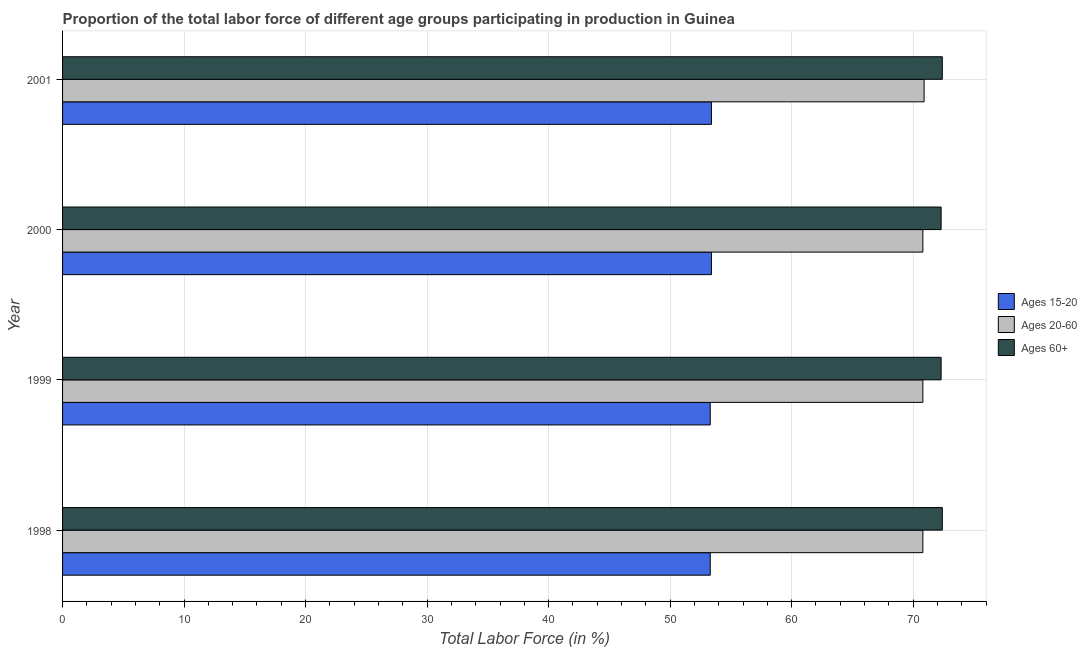Are the number of bars per tick equal to the number of legend labels?
Offer a very short reply. Yes. How many bars are there on the 4th tick from the bottom?
Your answer should be very brief. 3. What is the label of the 2nd group of bars from the top?
Ensure brevity in your answer.  2000. In how many cases, is the number of bars for a given year not equal to the number of legend labels?
Keep it short and to the point. 0. What is the percentage of labor force above age 60 in 2000?
Offer a terse response. 72.3. Across all years, what is the maximum percentage of labor force above age 60?
Keep it short and to the point. 72.4. Across all years, what is the minimum percentage of labor force within the age group 15-20?
Offer a terse response. 53.3. What is the total percentage of labor force within the age group 15-20 in the graph?
Offer a terse response. 213.4. What is the difference between the percentage of labor force within the age group 15-20 in 1999 and that in 2001?
Your response must be concise. -0.1. What is the difference between the percentage of labor force within the age group 15-20 in 1998 and the percentage of labor force above age 60 in 1999?
Ensure brevity in your answer.  -19. What is the average percentage of labor force above age 60 per year?
Your answer should be very brief. 72.35. In the year 2001, what is the difference between the percentage of labor force within the age group 20-60 and percentage of labor force within the age group 15-20?
Give a very brief answer. 17.5. What is the ratio of the percentage of labor force within the age group 20-60 in 1998 to that in 2000?
Your response must be concise. 1. Is the difference between the percentage of labor force above age 60 in 1998 and 1999 greater than the difference between the percentage of labor force within the age group 20-60 in 1998 and 1999?
Provide a succinct answer. Yes. What is the difference between the highest and the second highest percentage of labor force within the age group 15-20?
Your response must be concise. 0. What is the difference between the highest and the lowest percentage of labor force within the age group 15-20?
Provide a short and direct response. 0.1. In how many years, is the percentage of labor force within the age group 20-60 greater than the average percentage of labor force within the age group 20-60 taken over all years?
Your answer should be very brief. 1. Is the sum of the percentage of labor force above age 60 in 1998 and 2000 greater than the maximum percentage of labor force within the age group 20-60 across all years?
Your answer should be compact. Yes. What does the 1st bar from the top in 1998 represents?
Offer a very short reply. Ages 60+. What does the 2nd bar from the bottom in 1998 represents?
Offer a terse response. Ages 20-60. Is it the case that in every year, the sum of the percentage of labor force within the age group 15-20 and percentage of labor force within the age group 20-60 is greater than the percentage of labor force above age 60?
Offer a terse response. Yes. How many bars are there?
Your answer should be compact. 12. Are all the bars in the graph horizontal?
Provide a short and direct response. Yes. Does the graph contain any zero values?
Offer a very short reply. No. Where does the legend appear in the graph?
Your response must be concise. Center right. How many legend labels are there?
Provide a short and direct response. 3. What is the title of the graph?
Ensure brevity in your answer.  Proportion of the total labor force of different age groups participating in production in Guinea. Does "Agricultural raw materials" appear as one of the legend labels in the graph?
Your response must be concise. No. What is the label or title of the X-axis?
Give a very brief answer. Total Labor Force (in %). What is the Total Labor Force (in %) in Ages 15-20 in 1998?
Keep it short and to the point. 53.3. What is the Total Labor Force (in %) of Ages 20-60 in 1998?
Ensure brevity in your answer.  70.8. What is the Total Labor Force (in %) in Ages 60+ in 1998?
Give a very brief answer. 72.4. What is the Total Labor Force (in %) of Ages 15-20 in 1999?
Ensure brevity in your answer.  53.3. What is the Total Labor Force (in %) of Ages 20-60 in 1999?
Your answer should be compact. 70.8. What is the Total Labor Force (in %) of Ages 60+ in 1999?
Offer a very short reply. 72.3. What is the Total Labor Force (in %) in Ages 15-20 in 2000?
Your response must be concise. 53.4. What is the Total Labor Force (in %) of Ages 20-60 in 2000?
Keep it short and to the point. 70.8. What is the Total Labor Force (in %) in Ages 60+ in 2000?
Keep it short and to the point. 72.3. What is the Total Labor Force (in %) of Ages 15-20 in 2001?
Your answer should be compact. 53.4. What is the Total Labor Force (in %) in Ages 20-60 in 2001?
Offer a very short reply. 70.9. What is the Total Labor Force (in %) of Ages 60+ in 2001?
Provide a short and direct response. 72.4. Across all years, what is the maximum Total Labor Force (in %) of Ages 15-20?
Ensure brevity in your answer.  53.4. Across all years, what is the maximum Total Labor Force (in %) in Ages 20-60?
Offer a terse response. 70.9. Across all years, what is the maximum Total Labor Force (in %) in Ages 60+?
Give a very brief answer. 72.4. Across all years, what is the minimum Total Labor Force (in %) in Ages 15-20?
Keep it short and to the point. 53.3. Across all years, what is the minimum Total Labor Force (in %) in Ages 20-60?
Ensure brevity in your answer.  70.8. Across all years, what is the minimum Total Labor Force (in %) in Ages 60+?
Your answer should be compact. 72.3. What is the total Total Labor Force (in %) in Ages 15-20 in the graph?
Your answer should be very brief. 213.4. What is the total Total Labor Force (in %) of Ages 20-60 in the graph?
Offer a very short reply. 283.3. What is the total Total Labor Force (in %) of Ages 60+ in the graph?
Give a very brief answer. 289.4. What is the difference between the Total Labor Force (in %) of Ages 15-20 in 1998 and that in 1999?
Provide a succinct answer. 0. What is the difference between the Total Labor Force (in %) in Ages 15-20 in 1998 and that in 2000?
Your answer should be very brief. -0.1. What is the difference between the Total Labor Force (in %) of Ages 20-60 in 1998 and that in 2000?
Your answer should be very brief. 0. What is the difference between the Total Labor Force (in %) in Ages 60+ in 1998 and that in 2000?
Your answer should be compact. 0.1. What is the difference between the Total Labor Force (in %) in Ages 60+ in 1998 and that in 2001?
Provide a short and direct response. 0. What is the difference between the Total Labor Force (in %) in Ages 20-60 in 1999 and that in 2000?
Ensure brevity in your answer.  0. What is the difference between the Total Labor Force (in %) in Ages 60+ in 1999 and that in 2000?
Your response must be concise. 0. What is the difference between the Total Labor Force (in %) in Ages 60+ in 2000 and that in 2001?
Your response must be concise. -0.1. What is the difference between the Total Labor Force (in %) in Ages 15-20 in 1998 and the Total Labor Force (in %) in Ages 20-60 in 1999?
Ensure brevity in your answer.  -17.5. What is the difference between the Total Labor Force (in %) in Ages 15-20 in 1998 and the Total Labor Force (in %) in Ages 20-60 in 2000?
Your response must be concise. -17.5. What is the difference between the Total Labor Force (in %) of Ages 20-60 in 1998 and the Total Labor Force (in %) of Ages 60+ in 2000?
Provide a succinct answer. -1.5. What is the difference between the Total Labor Force (in %) in Ages 15-20 in 1998 and the Total Labor Force (in %) in Ages 20-60 in 2001?
Your response must be concise. -17.6. What is the difference between the Total Labor Force (in %) in Ages 15-20 in 1998 and the Total Labor Force (in %) in Ages 60+ in 2001?
Provide a short and direct response. -19.1. What is the difference between the Total Labor Force (in %) of Ages 15-20 in 1999 and the Total Labor Force (in %) of Ages 20-60 in 2000?
Give a very brief answer. -17.5. What is the difference between the Total Labor Force (in %) of Ages 15-20 in 1999 and the Total Labor Force (in %) of Ages 20-60 in 2001?
Your response must be concise. -17.6. What is the difference between the Total Labor Force (in %) in Ages 15-20 in 1999 and the Total Labor Force (in %) in Ages 60+ in 2001?
Offer a terse response. -19.1. What is the difference between the Total Labor Force (in %) of Ages 20-60 in 1999 and the Total Labor Force (in %) of Ages 60+ in 2001?
Ensure brevity in your answer.  -1.6. What is the difference between the Total Labor Force (in %) of Ages 15-20 in 2000 and the Total Labor Force (in %) of Ages 20-60 in 2001?
Your answer should be very brief. -17.5. What is the difference between the Total Labor Force (in %) of Ages 20-60 in 2000 and the Total Labor Force (in %) of Ages 60+ in 2001?
Keep it short and to the point. -1.6. What is the average Total Labor Force (in %) of Ages 15-20 per year?
Make the answer very short. 53.35. What is the average Total Labor Force (in %) in Ages 20-60 per year?
Provide a short and direct response. 70.83. What is the average Total Labor Force (in %) of Ages 60+ per year?
Your answer should be very brief. 72.35. In the year 1998, what is the difference between the Total Labor Force (in %) in Ages 15-20 and Total Labor Force (in %) in Ages 20-60?
Give a very brief answer. -17.5. In the year 1998, what is the difference between the Total Labor Force (in %) in Ages 15-20 and Total Labor Force (in %) in Ages 60+?
Offer a terse response. -19.1. In the year 1998, what is the difference between the Total Labor Force (in %) in Ages 20-60 and Total Labor Force (in %) in Ages 60+?
Ensure brevity in your answer.  -1.6. In the year 1999, what is the difference between the Total Labor Force (in %) of Ages 15-20 and Total Labor Force (in %) of Ages 20-60?
Keep it short and to the point. -17.5. In the year 2000, what is the difference between the Total Labor Force (in %) in Ages 15-20 and Total Labor Force (in %) in Ages 20-60?
Your answer should be compact. -17.4. In the year 2000, what is the difference between the Total Labor Force (in %) of Ages 15-20 and Total Labor Force (in %) of Ages 60+?
Provide a short and direct response. -18.9. In the year 2000, what is the difference between the Total Labor Force (in %) in Ages 20-60 and Total Labor Force (in %) in Ages 60+?
Offer a terse response. -1.5. In the year 2001, what is the difference between the Total Labor Force (in %) of Ages 15-20 and Total Labor Force (in %) of Ages 20-60?
Provide a short and direct response. -17.5. What is the ratio of the Total Labor Force (in %) in Ages 20-60 in 1998 to that in 1999?
Offer a terse response. 1. What is the ratio of the Total Labor Force (in %) in Ages 20-60 in 1998 to that in 2000?
Keep it short and to the point. 1. What is the ratio of the Total Labor Force (in %) in Ages 60+ in 1998 to that in 2001?
Your answer should be very brief. 1. What is the ratio of the Total Labor Force (in %) in Ages 15-20 in 1999 to that in 2000?
Keep it short and to the point. 1. What is the ratio of the Total Labor Force (in %) in Ages 20-60 in 1999 to that in 2000?
Keep it short and to the point. 1. What is the ratio of the Total Labor Force (in %) in Ages 15-20 in 1999 to that in 2001?
Make the answer very short. 1. What is the ratio of the Total Labor Force (in %) of Ages 20-60 in 1999 to that in 2001?
Make the answer very short. 1. What is the ratio of the Total Labor Force (in %) in Ages 60+ in 1999 to that in 2001?
Ensure brevity in your answer.  1. What is the ratio of the Total Labor Force (in %) in Ages 20-60 in 2000 to that in 2001?
Your answer should be very brief. 1. What is the ratio of the Total Labor Force (in %) of Ages 60+ in 2000 to that in 2001?
Make the answer very short. 1. What is the difference between the highest and the second highest Total Labor Force (in %) of Ages 15-20?
Make the answer very short. 0. What is the difference between the highest and the second highest Total Labor Force (in %) of Ages 20-60?
Provide a succinct answer. 0.1. What is the difference between the highest and the second highest Total Labor Force (in %) in Ages 60+?
Keep it short and to the point. 0. What is the difference between the highest and the lowest Total Labor Force (in %) in Ages 15-20?
Provide a short and direct response. 0.1. What is the difference between the highest and the lowest Total Labor Force (in %) of Ages 20-60?
Provide a short and direct response. 0.1. What is the difference between the highest and the lowest Total Labor Force (in %) in Ages 60+?
Offer a terse response. 0.1. 